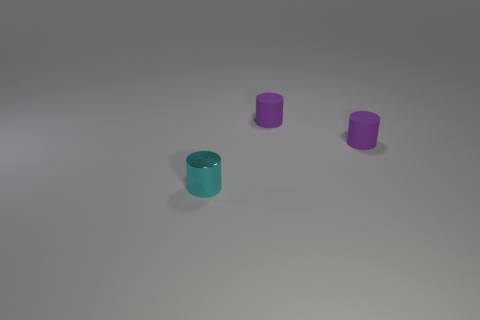How many objects are there in the image? There are three objects in the image. Two appear to be identical in shape and color, while one is distinct both in color and its orientation. Are the objects the same size? Yes, all three objects have the same cylindrical shape and size, indicating they could be part of a set or have a related purpose. 